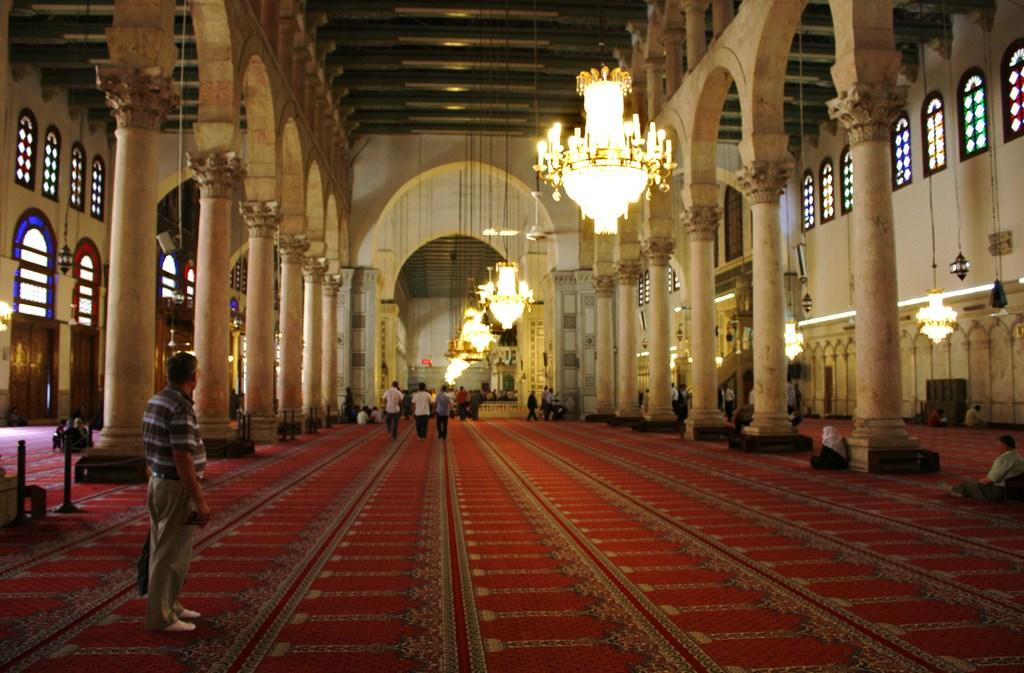What is the main subject of the image? There is a person standing in the image. What are the other people in the image doing? There are people walking in the image. Where is the image taken? The image is inside a building. What architectural features can be seen in the image? There are pillars visible in the image. What type of lighting is present in the image? There are chandeliers in the image. What is visible in the background of the image? There is a wall in the background of the image. How many apples are being accounted for in the image? There are no apples or any reference to accounting in the image. What effect does the lighting have on the people in the image? The image does not show any specific effect of the lighting on the people; it only depicts the presence of chandeliers. 